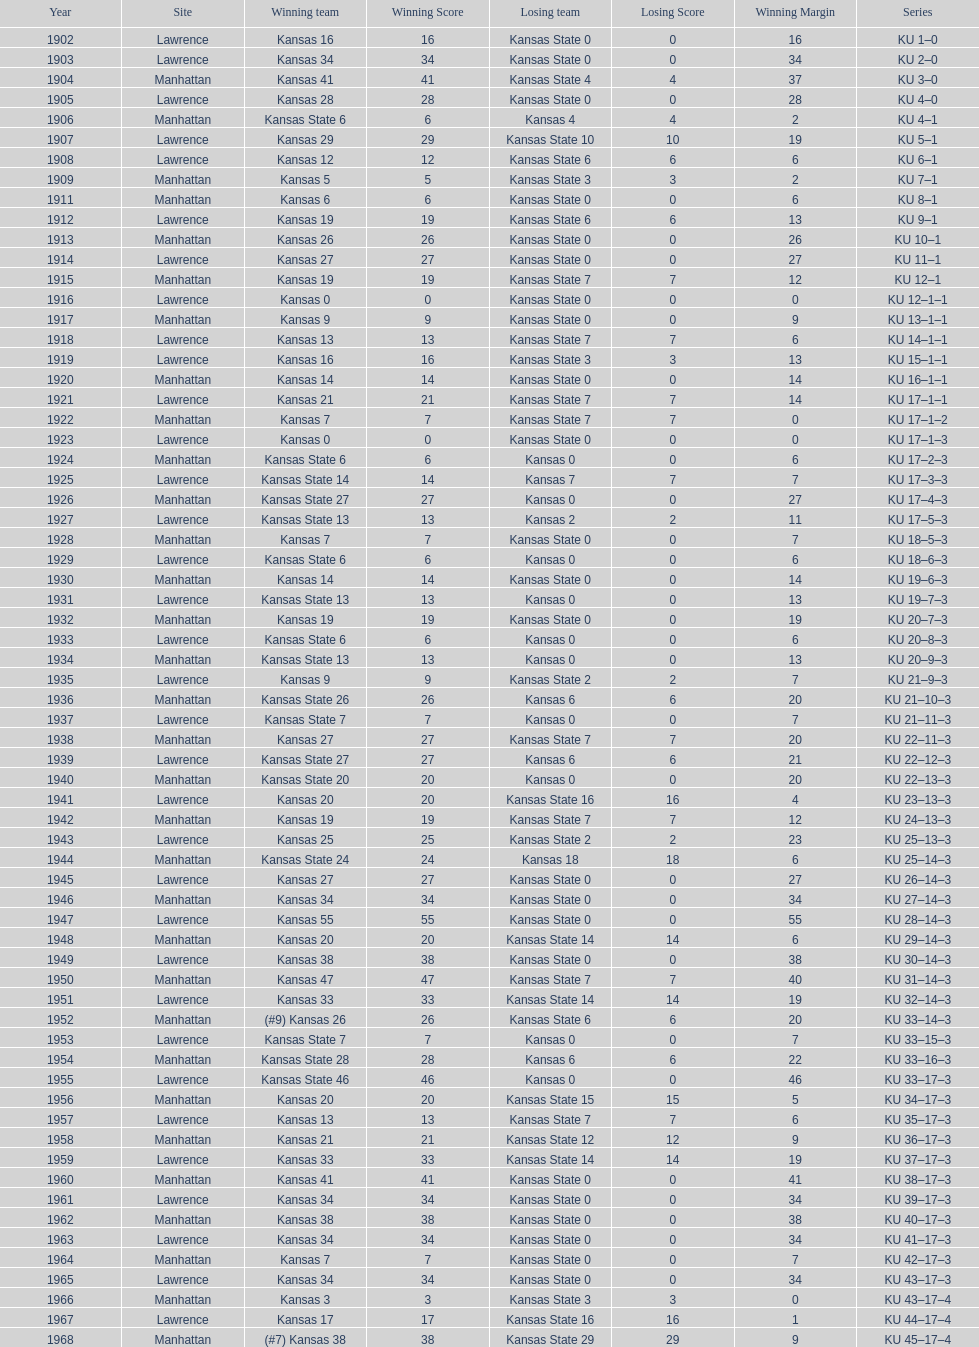How many times did kansas and kansas state play in lawrence from 1902-1968? 34. 